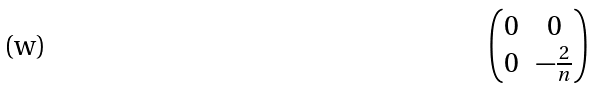<formula> <loc_0><loc_0><loc_500><loc_500>\begin{pmatrix} 0 & 0 \\ 0 & - \frac { 2 } { n } \end{pmatrix}</formula> 